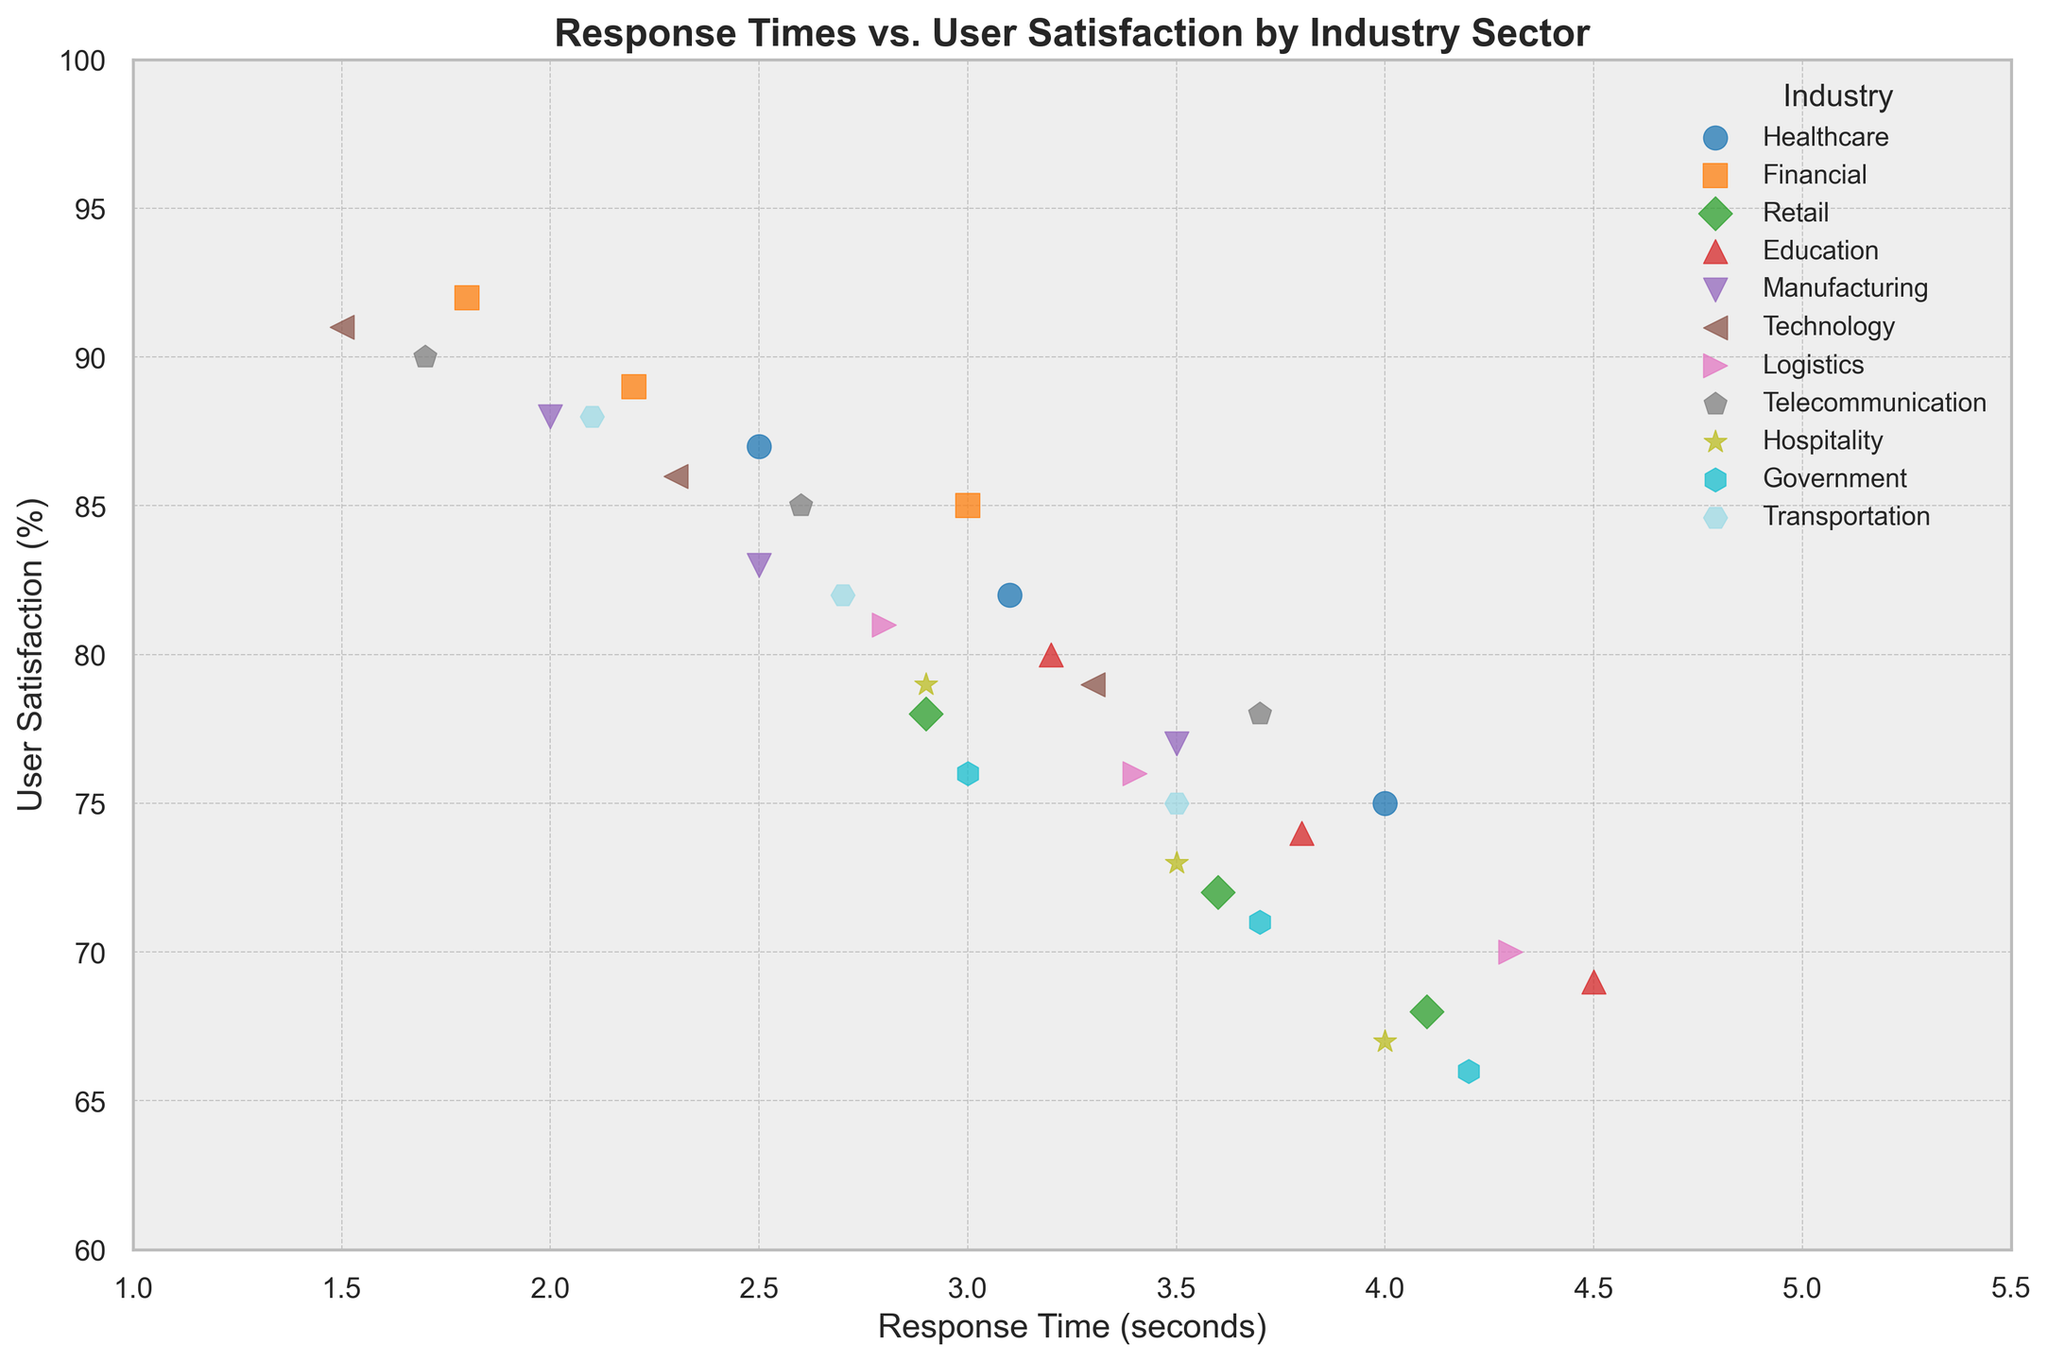Which industry sector has the highest user satisfaction? By identifying the highest point on the y-axis (User Satisfaction) and following it to its corresponding x-axis (Response Time), we can find the industry sector. The highest user satisfaction is 92, which corresponds to the Financial sector.
Answer: Financial Which industry sector has the lowest user satisfaction? By identifying the lowest point on the y-axis (User Satisfaction) and following it to its corresponding x-axis (Response Time), we can find the industry sector. The lowest user satisfaction is 66, which corresponds to the Government sector.
Answer: Government What is the general trend between response time and user satisfaction? A general trend can be identified by observing the spread of data points. As response time increases on the x-axis, user satisfaction tends to decrease on the y-axis.
Answer: Negative correlation Which industry sector has the most variation in user satisfaction? The variation in user satisfaction can be seen by observing the spread of points for an industry along the y-axis. The Government sector has points ranging from 66 to 76, indicating higher variation.
Answer: Government Which industry sector shows the highest overlap in response time and user satisfaction? By observing clusters of data points, we can identify overlapping sectors. The response times from 2.9 to 3.6 seconds and user satisfaction from 72 to 79% show overlap between the Retail, Hospitality, and Logistics sectors.
Answer: Retail, Hospitality, Logistics For the Healthcare sector, what is the difference in user satisfaction between the highest and lowest response times? By checking the user satisfaction for the highest (3.1 seconds, 82%) and lowest (4.0 seconds, 75%) response times in Healthcare, we find the difference is 82 - 75 = 7%.
Answer: 7% Which industry sector shows a user satisfaction rate around 80% but in different response times? The Education sector shows user satisfaction close to 80%, with response times at 3.2 and 3.8 seconds.
Answer: Education What is the average response time for the Technology sector? Adding the response times for the Technology sector (1.5, 2.3, 3.3) and dividing by the number of data points, the average is (1.5 + 2.3 + 3.3) / 3 = 2.37 seconds.
Answer: 2.37 seconds How does the user satisfaction for the Financial sector compare to the Telecommunications sector at similar response times? Comparing response times around 2.2 to 2.6 seconds, Financial sector has user satisfaction around 89, while Telecommunications sector shows 85.
Answer: Financial sector has higher satisfaction In which industry sector is the response time variability the least? By observing the range of response times for each sector, we see that the Transportation sector has response times between 2.1 and 3.5, indicating the least variability (1.4 seconds).
Answer: Transportation 